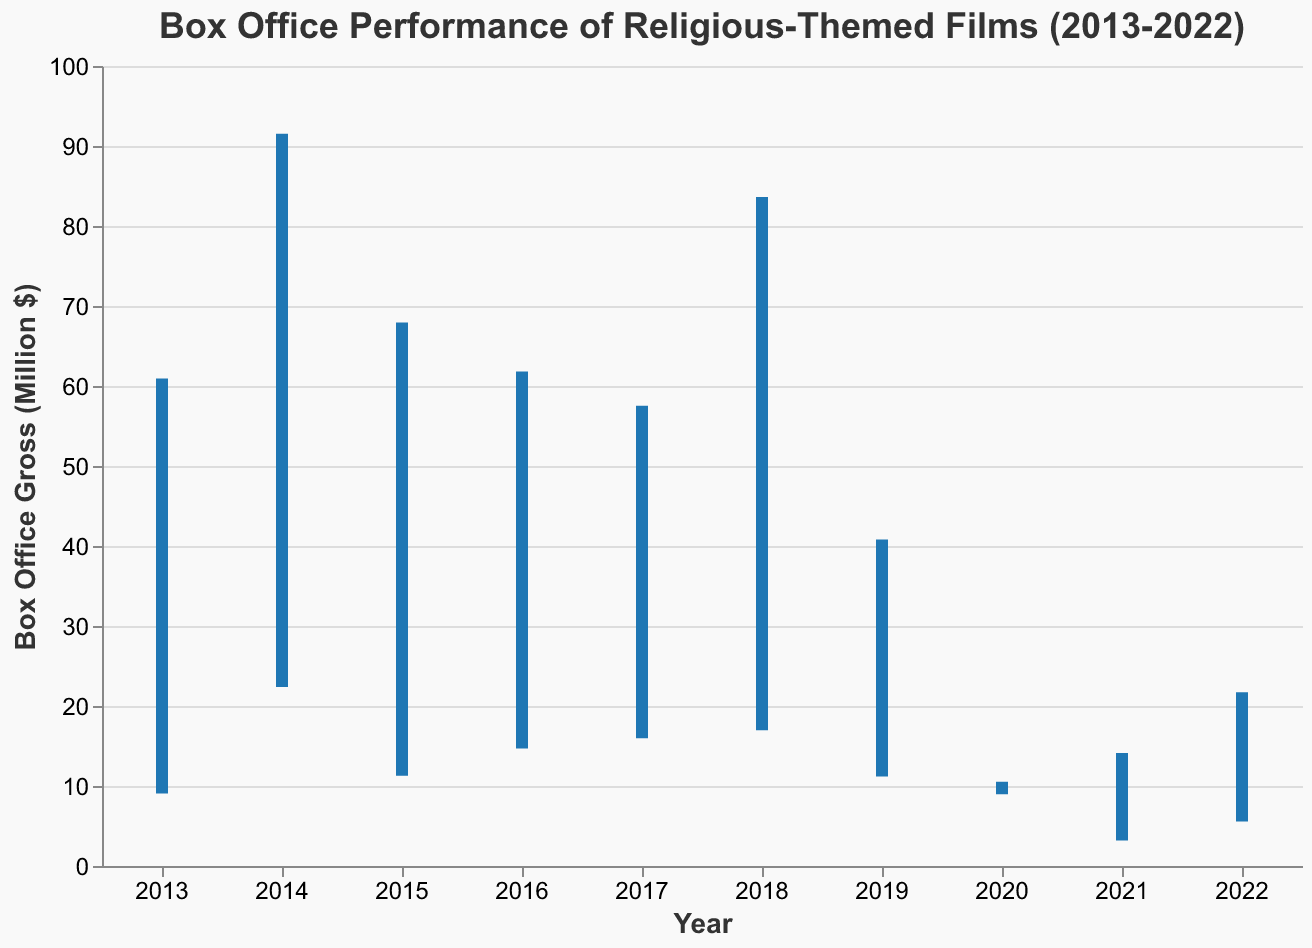What's the highest grossing religious-themed film in the chart? To determine the highest grossing film, look for the highest value in the "Highest Gross" column of the chart. "Heaven Is for Real" in 2014 has the highest gross of $91.4 million.
Answer: "Heaven Is for Real" with $91.4 million Which film had the lowest opening weekend gross? Find the lowest value in the "Opening Weekend" column. "The Chosen Season 1" in 2021 had the lowest opening weekend gross of $3.3 million.
Answer: "The Chosen Season 1" with $3.3 million What is the difference in highest gross between "War Room" and "Breakthrough"? Subtract the highest gross of "Breakthrough" from "War Room". For "War Room", it's $67.8 million, and for "Breakthrough", it's $40.7 million. The difference is $67.8 million - $40.7 million = $27.1 million.
Answer: $27.1 million Which year had the highest average gross, considering both opening and closing figures? The average gross for a year can be calculated by taking the sum of the opening weekend and closing gross for films in that year, then dividing by the number of films. For simplicity, in 2014 (only one film), "Heaven Is for Real" with both opening and closing gross of $22.5 million and $91.4 million, respectively, gives the total gross of 22.5 + 91.4 = 113.9 million, average gross of 113.9/2 = 56.95 million. Compare this with other years similarly.
Answer: 2014 with an average gross of $56.95 million Which film had the smallest range in box office gross from lowest to highest? To determine this, find the difference between the "Highest Gross" and "Lowest Gross" for each film, and identify the smallest difference. "I Still Believe" in 2020 has a range of $10.4 million - $9.1 million = $1.3 million.
Answer: "I Still Believe" How many films had a closing gross equal to their highest gross? Count the number of films where the values in the "Highest Gross" and "Closing Gross" columns are the same. All films in the dataset have matching "Highest Gross" and "Closing Gross".
Answer: 10 films Which film performed better in its opening weekend, "God's Not Dead" or "Father Stu"? Compare the "Opening Weekend" values for "God's Not Dead" ($9.2 million) and "Father Stu" ($5.7 million). "God's Not Dead" had a higher opening weekend gross.
Answer: "God's Not Dead" What is the lowest gross of any film in the chart? Review the "Lowest Gross" column to find the minimum value. The lowest value is $3.3 million recorded by "The Chosen Season 1" in 2021.
Answer: $3.3 million Of the films that debuted after 2015, which one had the highest opening weekend gross? Look at the "Opening Weekend" values for films from 2016 onwards, and identify the highest. "I Can Only Imagine" in 2018 had the highest opening weekend gross of $17.1 million.
Answer: "I Can Only Imagine" 